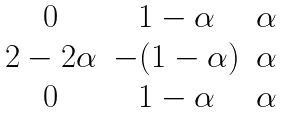<formula> <loc_0><loc_0><loc_500><loc_500>\begin{matrix} 0 & 1 - \alpha & \alpha \\ 2 - 2 \alpha & - ( 1 - \alpha ) & \alpha \\ 0 & 1 - \alpha & \alpha \end{matrix}</formula> 